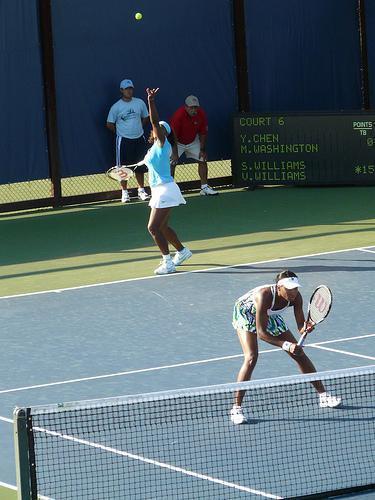How many women are in this picture?
Give a very brief answer. 2. 